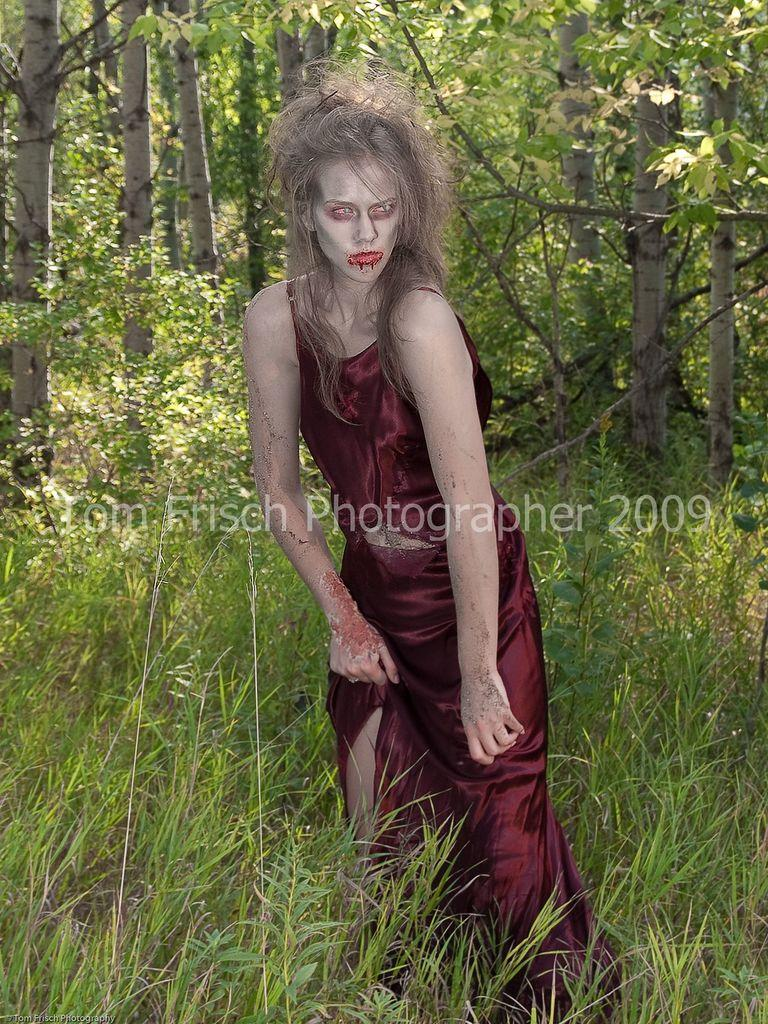Who is the main subject in the image? There is a woman in the image. What is the woman wearing in the image? The woman is dressed in a Halloween costume. What is the woman standing on in the image? The woman is standing on the surface of the grass. What can be seen in the background of the image? There are trees behind the woman. What type of body language does the woman exhibit towards the cushion in the image? There is no cushion present in the image, so it is not possible to determine the woman's body language towards a cushion. 